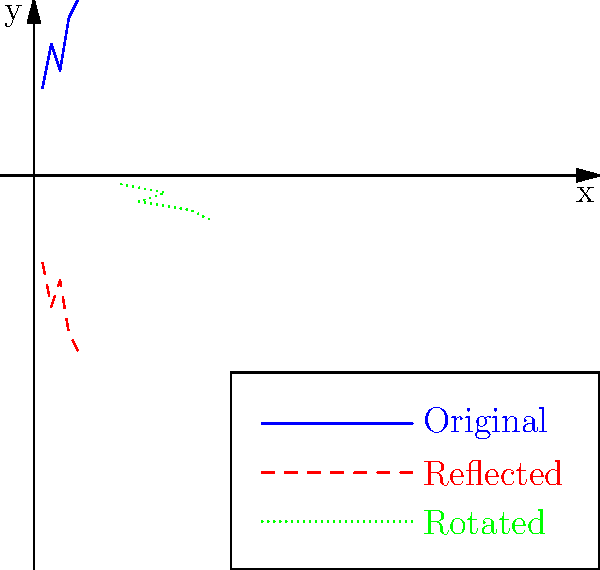A financial data graph shows a company's quarterly earnings. After applying a reflection across the x-axis and then a 90-degree clockwise rotation, you notice a hidden pattern that suggests potential fraud. If the original data points were $(1, 10)$, $(2, 15)$, $(3, 12)$, $(4, 18)$, and $(5, 20)$, what are the coordinates of the final transformed point that was originally $(4, 18)$? To solve this problem, we need to apply two transformations sequentially:

1. Reflection across the x-axis:
   - This transformation changes the sign of the y-coordinate.
   - $(4, 18)$ becomes $(4, -18)$

2. 90-degree clockwise rotation:
   - This transformation can be achieved by switching x and y coordinates and then negating the new y-coordinate.
   - $(4, -18)$ becomes $(18, -4)$

Step-by-step process:
1. Original point: $(4, 18)$
2. After reflection: $(4, -18)$
3. After rotation: $(18, -4)$

Therefore, the final transformed point is $(18, -4)$.
Answer: $(18, -4)$ 